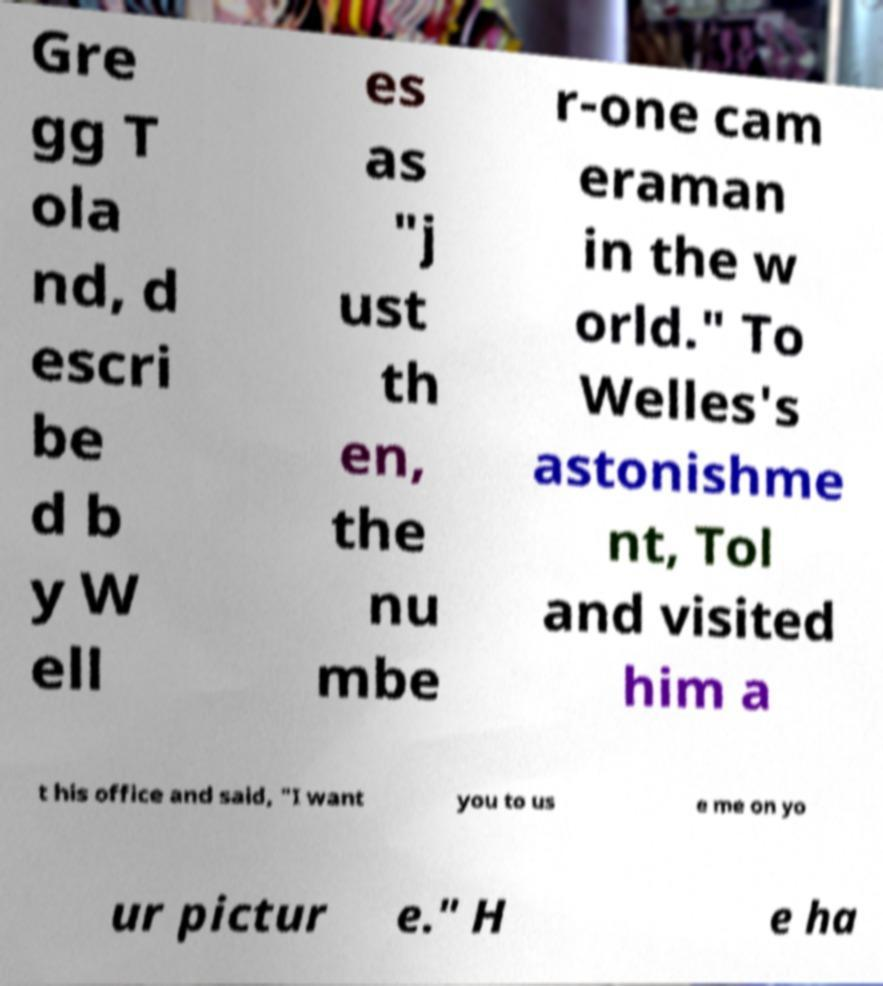Can you read and provide the text displayed in the image?This photo seems to have some interesting text. Can you extract and type it out for me? Gre gg T ola nd, d escri be d b y W ell es as "j ust th en, the nu mbe r-one cam eraman in the w orld." To Welles's astonishme nt, Tol and visited him a t his office and said, "I want you to us e me on yo ur pictur e." H e ha 